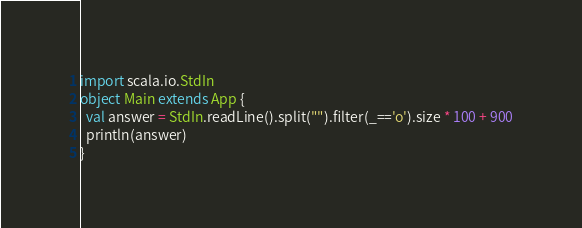Convert code to text. <code><loc_0><loc_0><loc_500><loc_500><_Scala_>import scala.io.StdIn
object Main extends App {
  val answer = StdIn.readLine().split("").filter(_=='o').size * 100 + 900
  println(answer)
}
</code> 